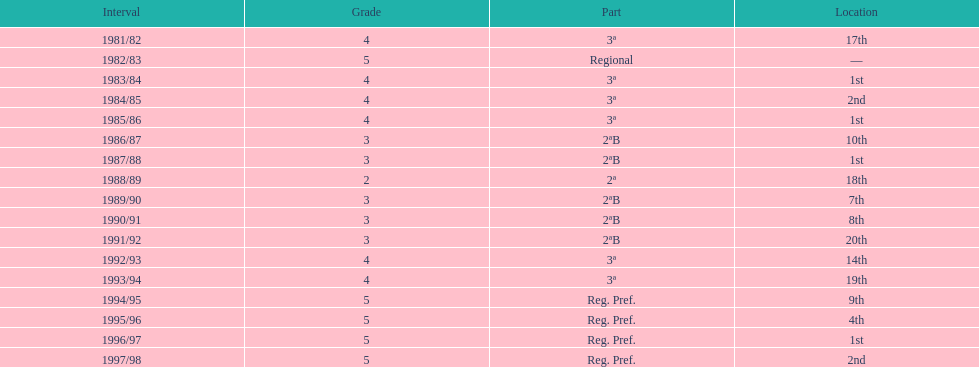Which season(s) earned first place? 1983/84, 1985/86, 1987/88, 1996/97. 